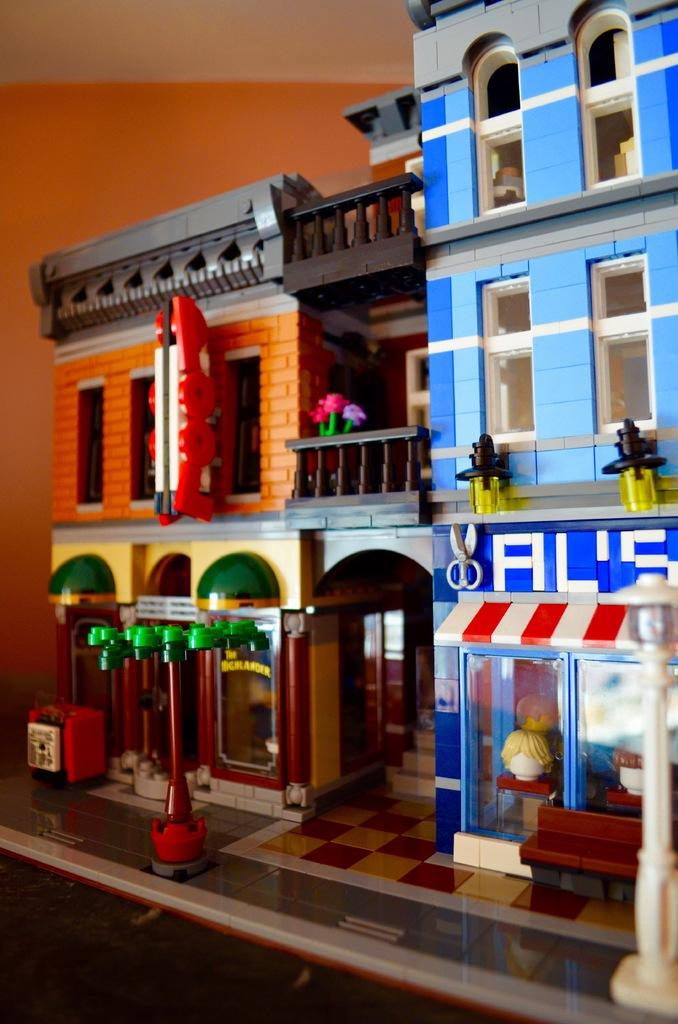What type of objects are present in the image? There are toy houses in the image. What is the background of the image? There is a wall in the image. What part of the toy houses can be seen in the image? The roof is visible in the image. How does the spy use the hook to copy the toy houses in the image? There is no spy, hook, or copying activity present in the image. The image only features toy houses, a wall, and a visible roof. 